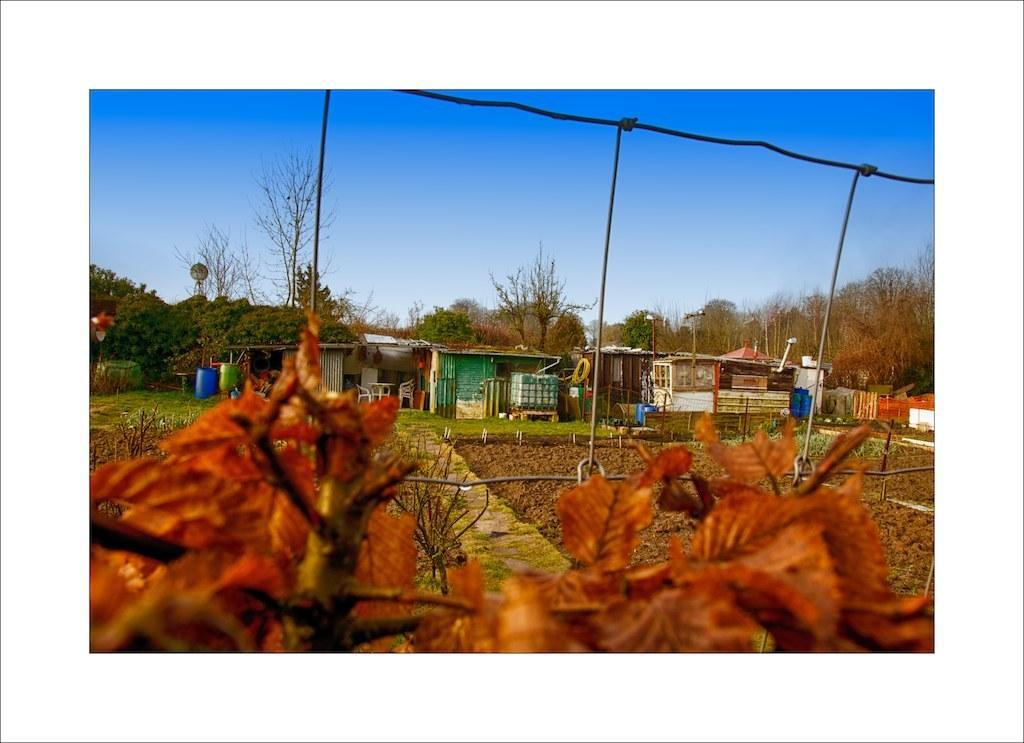How would you summarize this image in a sentence or two? In this image I can see number of brown colour leaves and iron net in the front. In the background I can see an open grass ground, few buildings, number of trees and the sky. I can also see few blue colored containers in the background. 